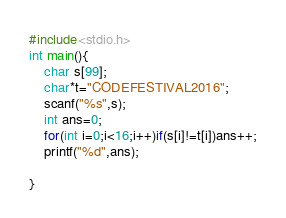<code> <loc_0><loc_0><loc_500><loc_500><_C_>#include<stdio.h>
int main(){
	char s[99];
	char*t="CODEFESTIVAL2016";
	scanf("%s",s);
	int ans=0;
	for(int i=0;i<16;i++)if(s[i]!=t[i])ans++;
	printf("%d",ans);
	
}</code> 